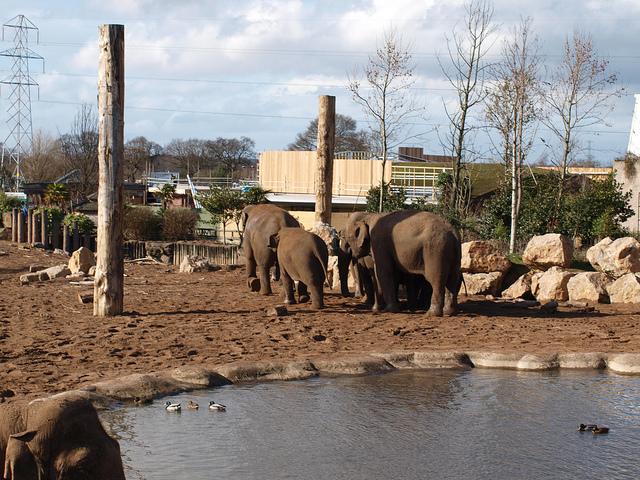What type of animals are in this scene?
Keep it brief. Elephants. How many elephants are standing near the wall?
Answer briefly. 3. What is in the pond?
Quick response, please. Ducks. 